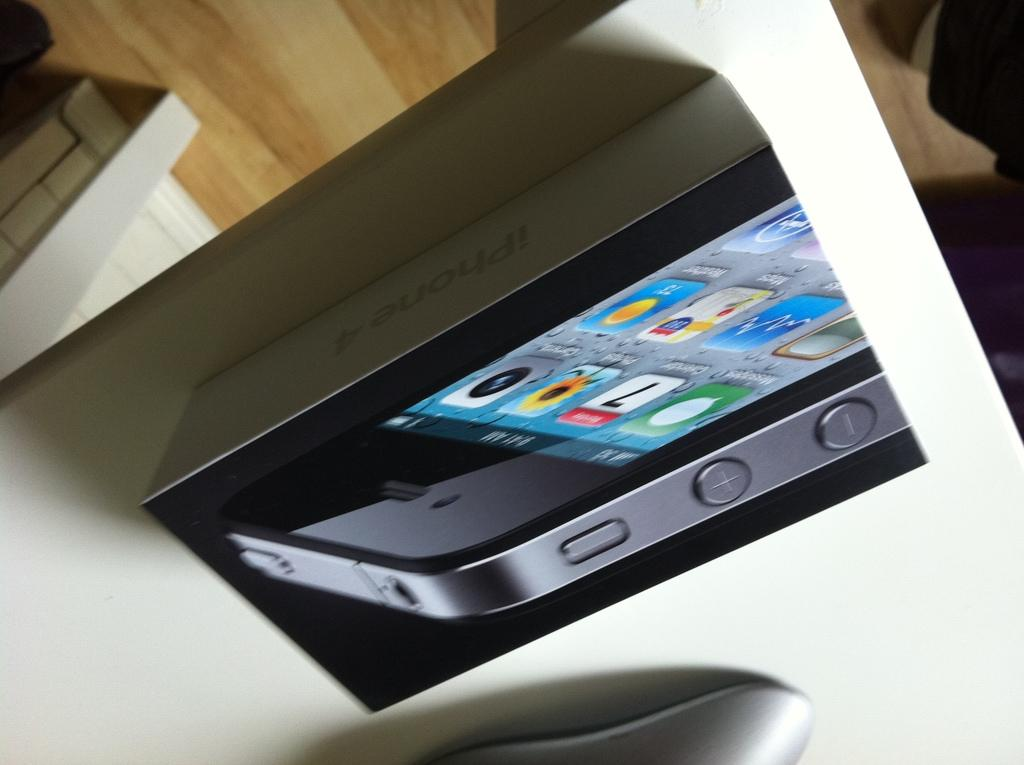<image>
Share a concise interpretation of the image provided. An iPhone 4 box has a photo of a phone showing the date on the calendar app as the 7th. 